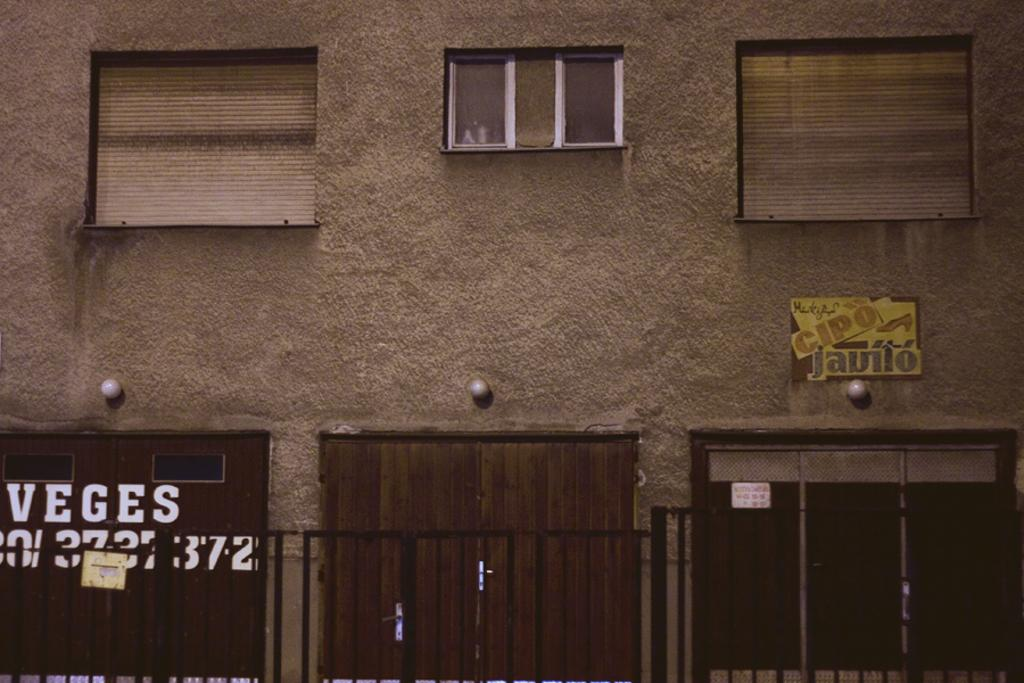What is present on the wall in the image? There is a window and papers on the wall in the image. How is the window covered or protected? There are two curtains, one on the right side and one on the left side of the window. What other architectural features can be seen in the image? There are doors visible in the image. Can you describe the window's location on the wall? The window is on the wall in the image. How many dolls are playing volleyball in the image? There are no dolls or volleyballs present in the image. What type of snakes can be seen slithering on the wall in the image? There are no snakes visible in the image. 